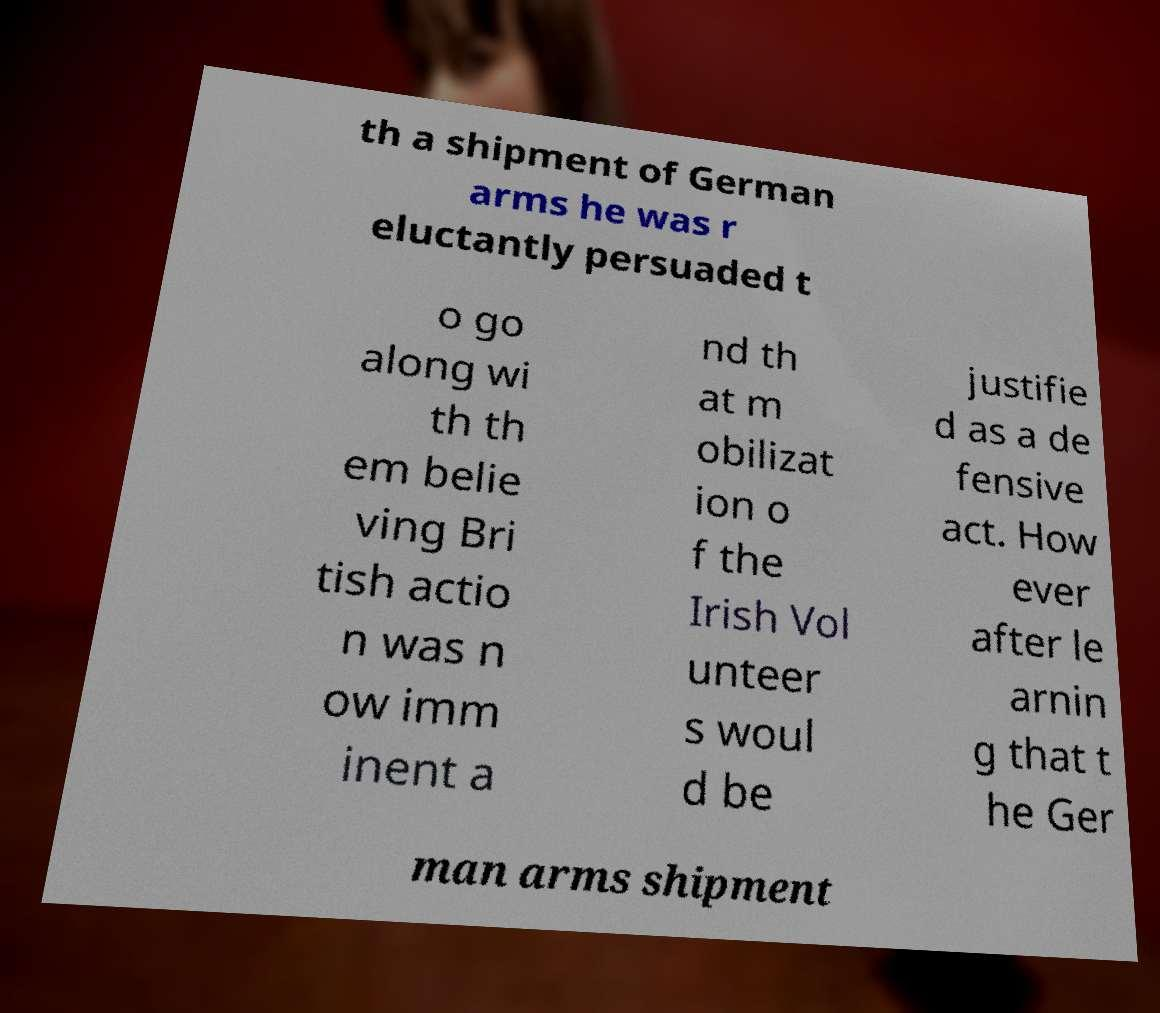Can you accurately transcribe the text from the provided image for me? th a shipment of German arms he was r eluctantly persuaded t o go along wi th th em belie ving Bri tish actio n was n ow imm inent a nd th at m obilizat ion o f the Irish Vol unteer s woul d be justifie d as a de fensive act. How ever after le arnin g that t he Ger man arms shipment 